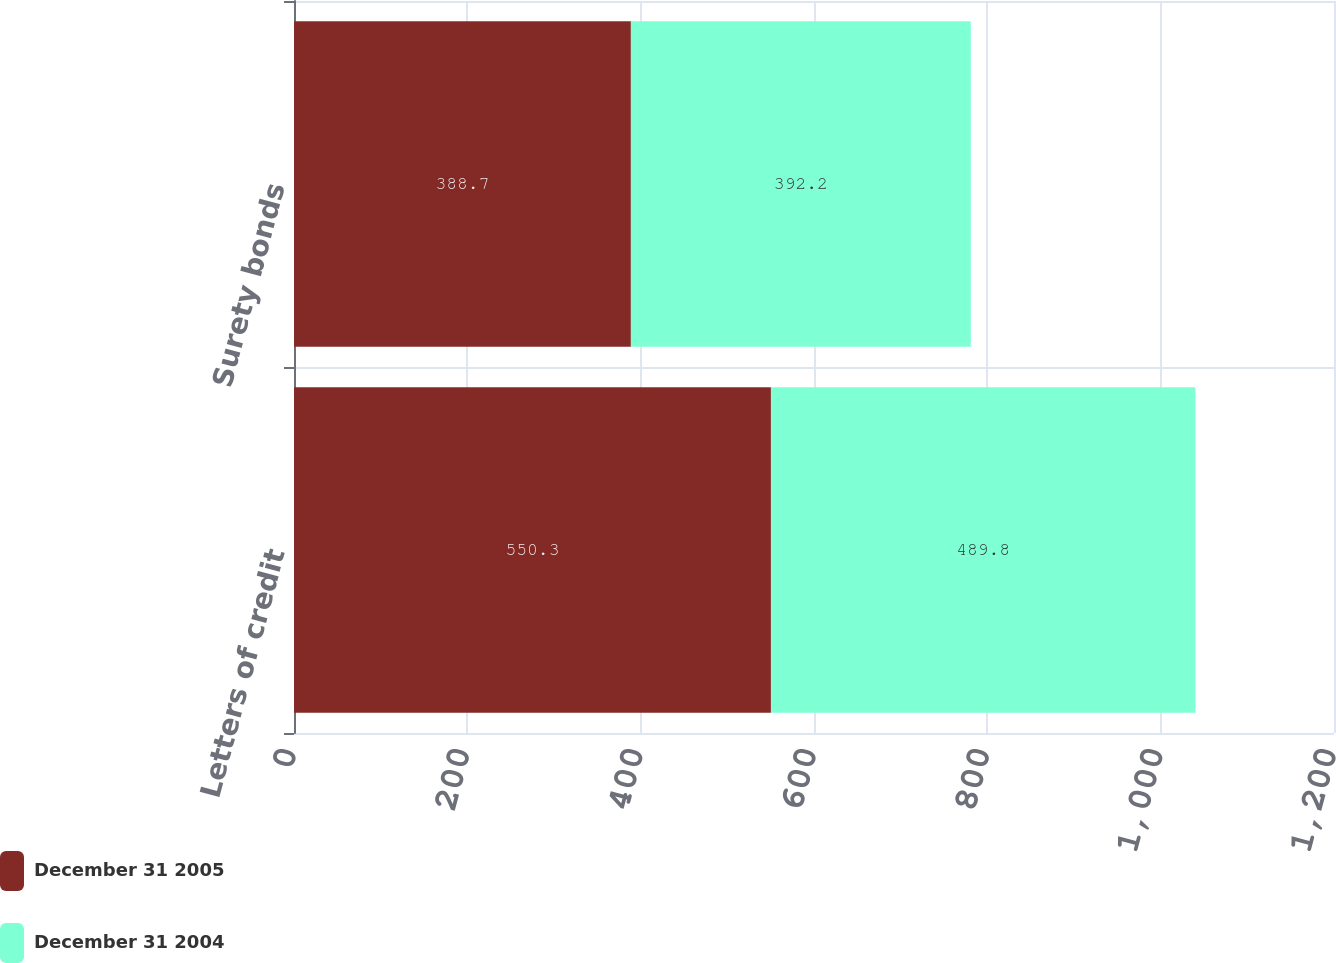Convert chart to OTSL. <chart><loc_0><loc_0><loc_500><loc_500><stacked_bar_chart><ecel><fcel>Letters of credit<fcel>Surety bonds<nl><fcel>December 31 2005<fcel>550.3<fcel>388.7<nl><fcel>December 31 2004<fcel>489.8<fcel>392.2<nl></chart> 